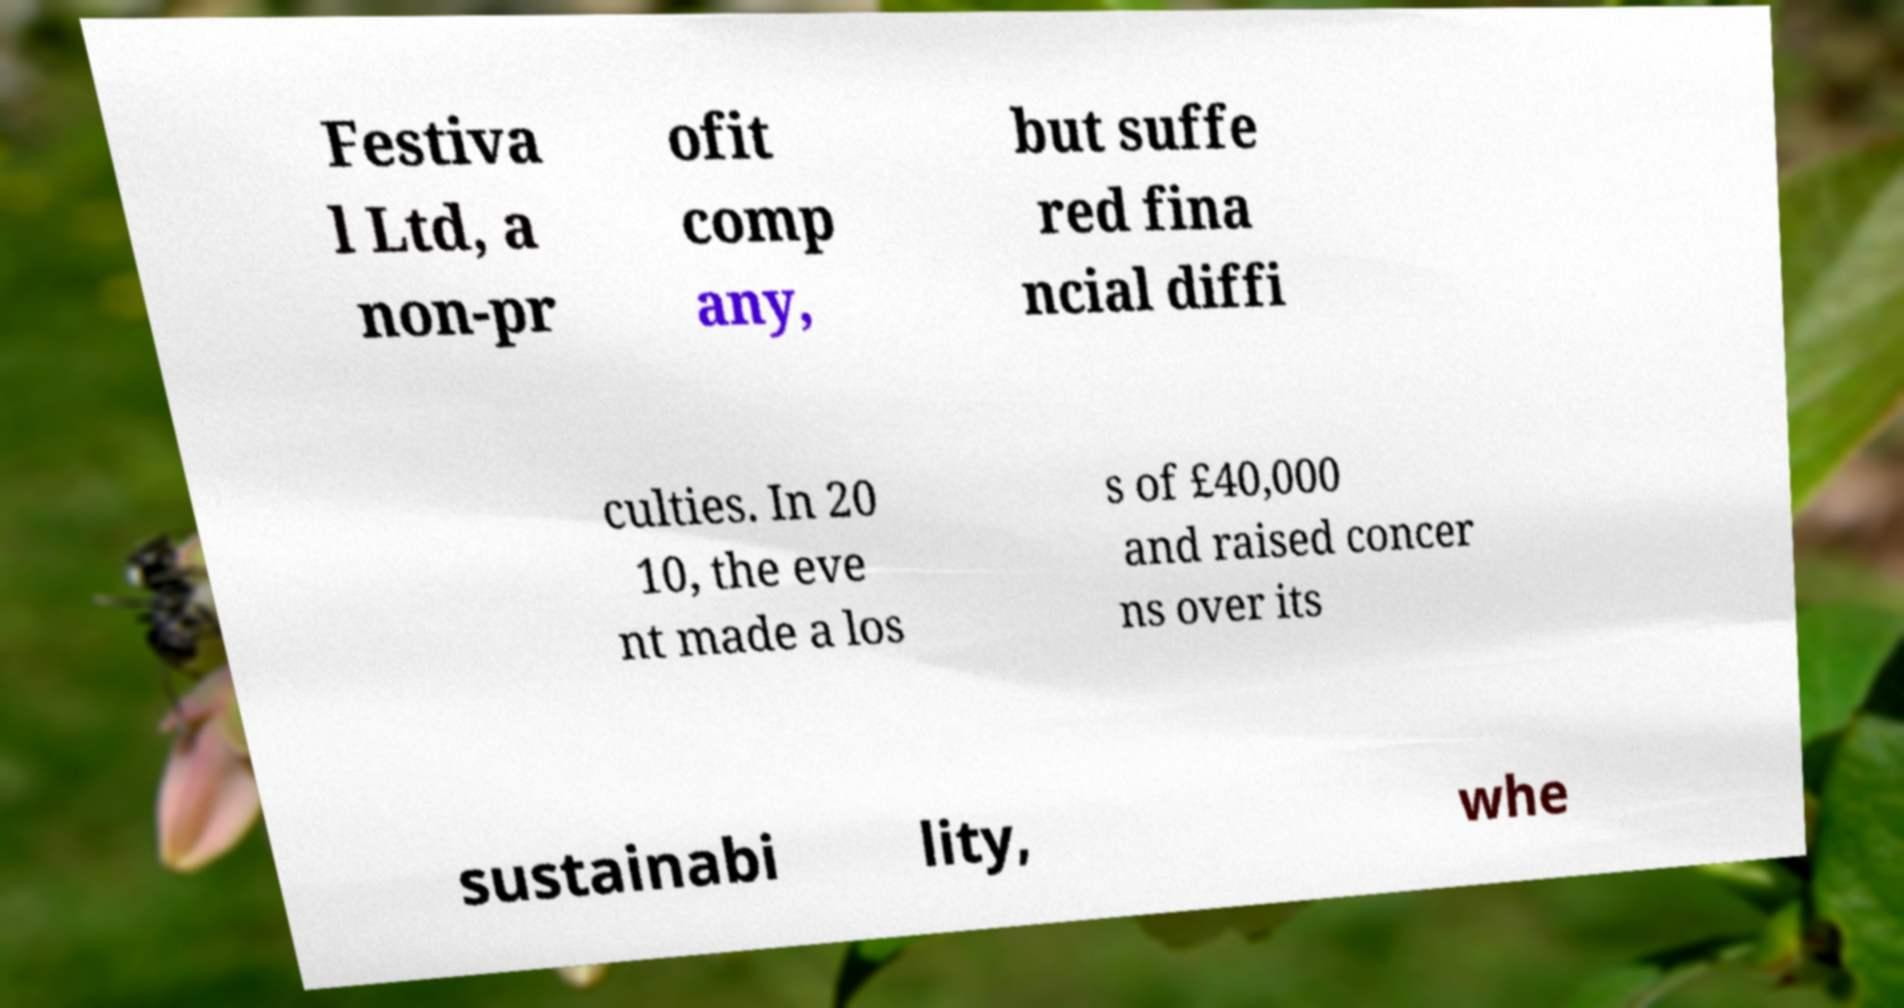Could you assist in decoding the text presented in this image and type it out clearly? Festiva l Ltd, a non-pr ofit comp any, but suffe red fina ncial diffi culties. In 20 10, the eve nt made a los s of £40,000 and raised concer ns over its sustainabi lity, whe 